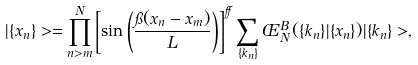<formula> <loc_0><loc_0><loc_500><loc_500>| \{ x _ { n } \} > = \prod _ { n > m } ^ { N } \left [ \sin \left ( \frac { \pi ( x _ { n } - x _ { m } ) } { L } \right ) \right ] ^ { \alpha } \sum _ { \{ k _ { n } \} } \phi _ { N } ^ { B } ( \{ k _ { n } \} | \{ x _ { n } \} ) | \{ k _ { n } \} > ,</formula> 